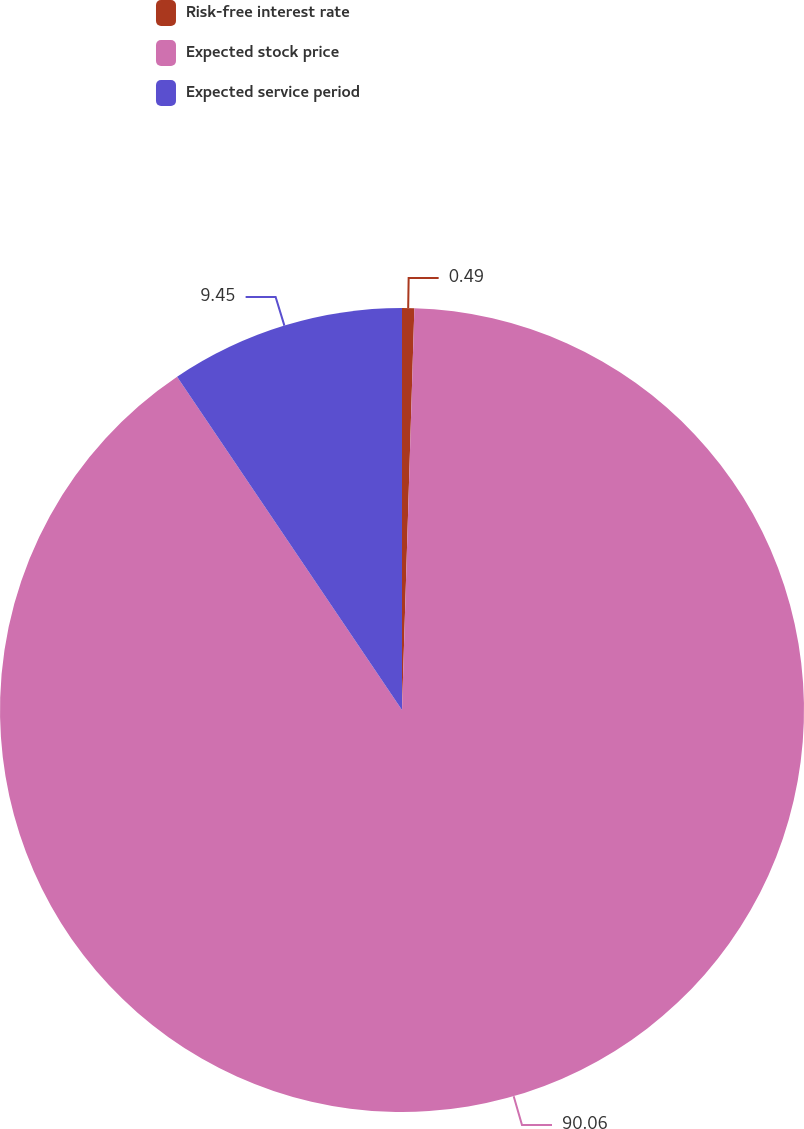Convert chart. <chart><loc_0><loc_0><loc_500><loc_500><pie_chart><fcel>Risk-free interest rate<fcel>Expected stock price<fcel>Expected service period<nl><fcel>0.49%<fcel>90.06%<fcel>9.45%<nl></chart> 